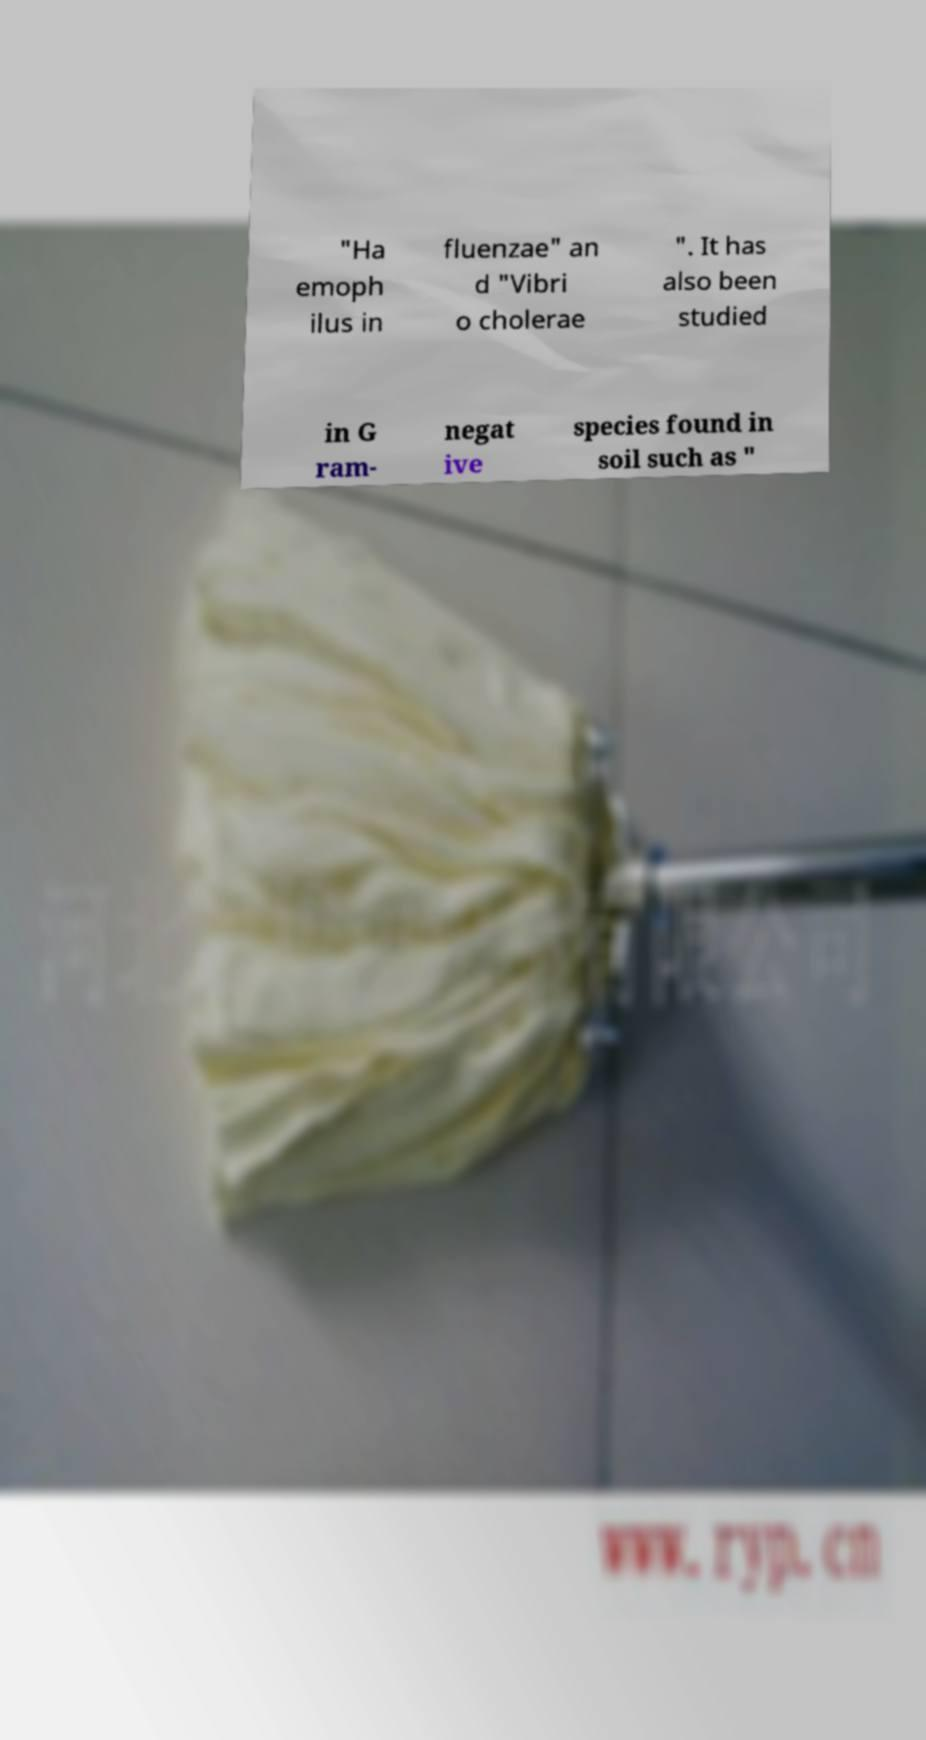Can you read and provide the text displayed in the image?This photo seems to have some interesting text. Can you extract and type it out for me? "Ha emoph ilus in fluenzae" an d "Vibri o cholerae ". It has also been studied in G ram- negat ive species found in soil such as " 